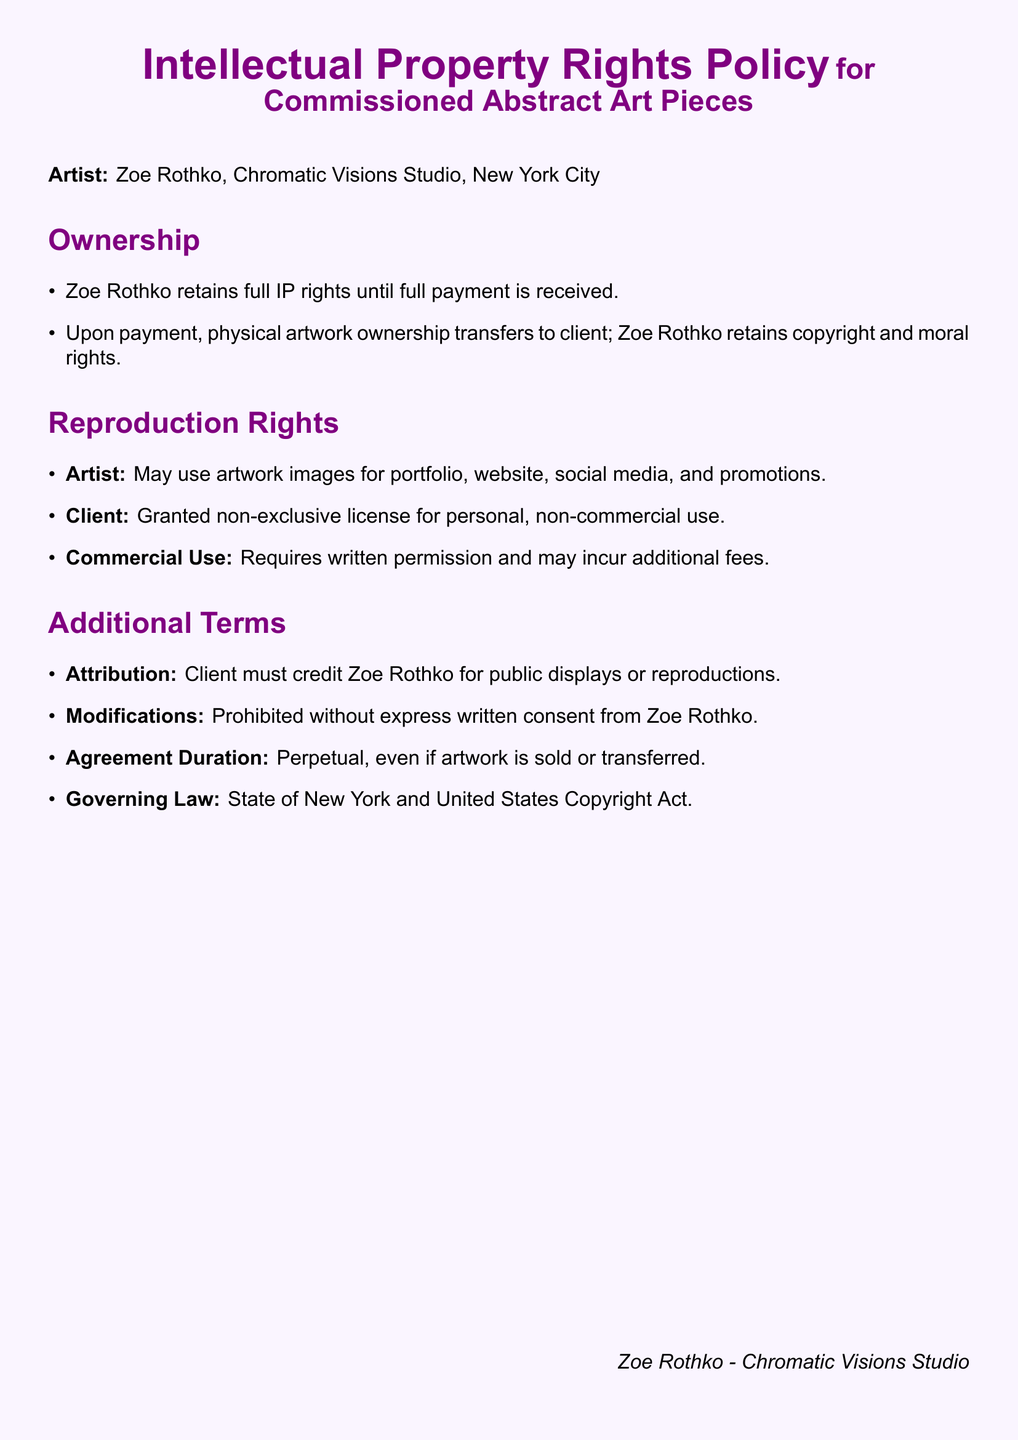What is the name of the artist? The name of the artist is mentioned at the beginning of the document.
Answer: Zoe Rothko What studio is associated with the artist? The studio associated with the artist is specified in the document.
Answer: Chromatic Visions Studio What city is the studio located in? The city where the studio is located is provided in the document.
Answer: New York City When do ownership rights transfer to the client? The condition for the transfer of ownership is stated in the document.
Answer: Upon full payment What type of license is granted to the client? The document specifies the type of license given to the client for artwork use.
Answer: Non-exclusive license for personal, non-commercial use What is required for commercial use of the artwork? The document mentions conditions that must be met for commercial use of the artwork.
Answer: Written permission What must the client do for public displays? The document outlines a requirement that the client must fulfill for public displays.
Answer: Credit Zoe Rothko Are modifications to the artwork allowed? The document specifies the rules about alterations to the original artwork.
Answer: Prohibited without express written consent Under which law is the agreement governed? The document states the governing law for the agreement.
Answer: New York and United States Copyright Act 